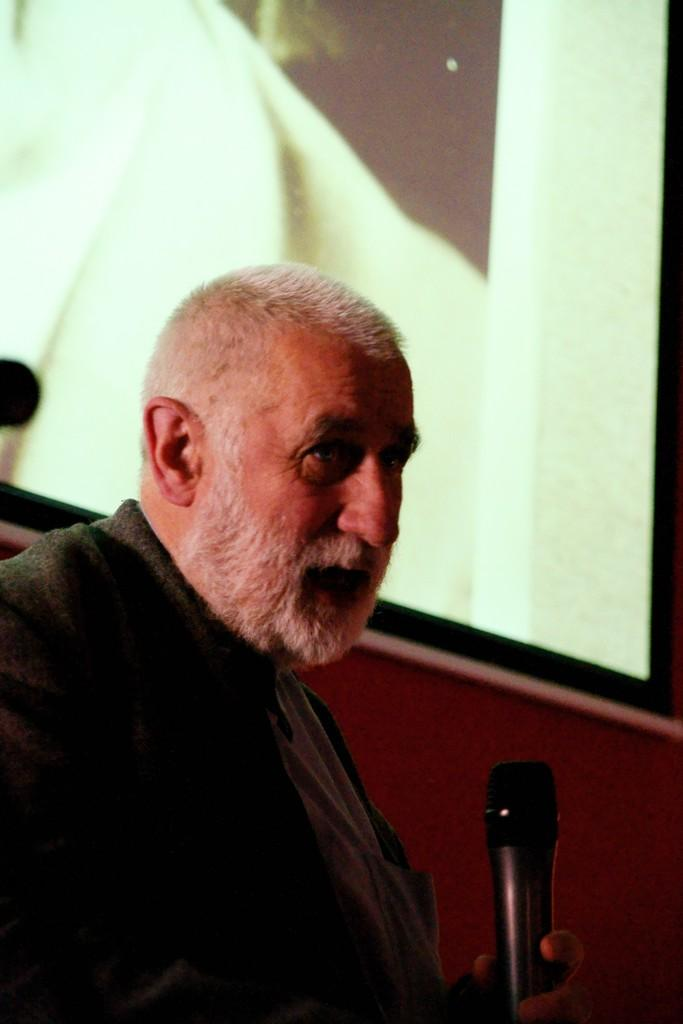What is the appearance of the person in the image? There is a person with a white beard in the image. What type of clothing is the person wearing? The person is wearing a jacket. What is the person holding in their left hand? The person is holding a mic in their left hand. What can be seen in the background of the image? There is a big screen in the background of the image. What type of humor can be seen in the image? There is no humor present in the image. --- Facts: 1. There is a person with a white beard in the image. 2. The person is wearing a jacket. 3. The person is holding a mic in their left hand. 4. There is a big screen in the background of the image. Absurd Topics: humor, wilderness, book Conversation: What is the appearance of the person in the image? There is a person with a white beard in the image. What type of clothing is the person wearing in the image? The person is wearing a jacket in the image. What is the person holding in their left hand in the image? The person is holding a mic in their left hand in the image. What can be seen in the background of the image? There is a big screen in the background of the image. Reasoning: Let's think step by step in order to produce the conversation. We start by identifying the main subject of the image, which is the person with a white beard. Next, we describe specific features of the person, such as the type of clothing they are wearing, which is a jacket. Then, we observe what the person is holding, which is a mic in their left hand. Finally, we describe the background element, which is a big screen. Absurd Question/Answer: What type of wilderness can be seen in the image? There is no wilderness present in the image. --- Facts: 1. There is a bowl of ice cream in the image. 2. There are sweets in the image. 3. Plastic spoons are visible in the image. 4. There is a mobile on the table in the image. 5. Napkins are present in the image. Absurd Topics: move, walk, crib Conversation: What is in the bowl that is visible in the image? There is a bowl of ice cream in the image. Besides ice cream, what other items can be seen in the image? There are sweets and plastic spoons visible in the image. Where is the mobile located in the image? The mobile is on the table in the image. What might be used for cleaning or wiping in the image? Napkins are present in the image for cleaning or wiping. Reasoning: Let's think step by step in order to produce the conversation. We start by identifying the main subject in 